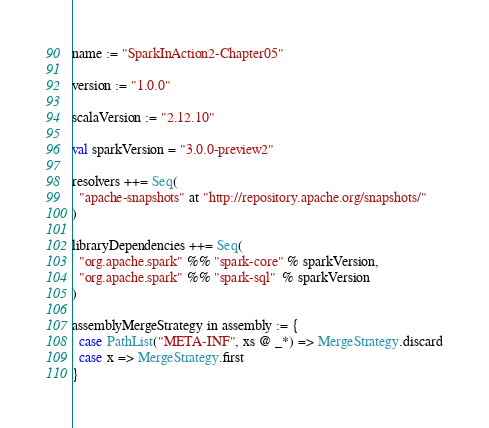Convert code to text. <code><loc_0><loc_0><loc_500><loc_500><_Scala_>name := "SparkInAction2-Chapter05"

version := "1.0.0"

scalaVersion := "2.12.10"

val sparkVersion = "3.0.0-preview2"

resolvers ++= Seq(
  "apache-snapshots" at "http://repository.apache.org/snapshots/"
)

libraryDependencies ++= Seq(
  "org.apache.spark" %% "spark-core" % sparkVersion,
  "org.apache.spark" %% "spark-sql"  % sparkVersion
)

assemblyMergeStrategy in assembly := {
  case PathList("META-INF", xs @ _*) => MergeStrategy.discard
  case x => MergeStrategy.first
}</code> 